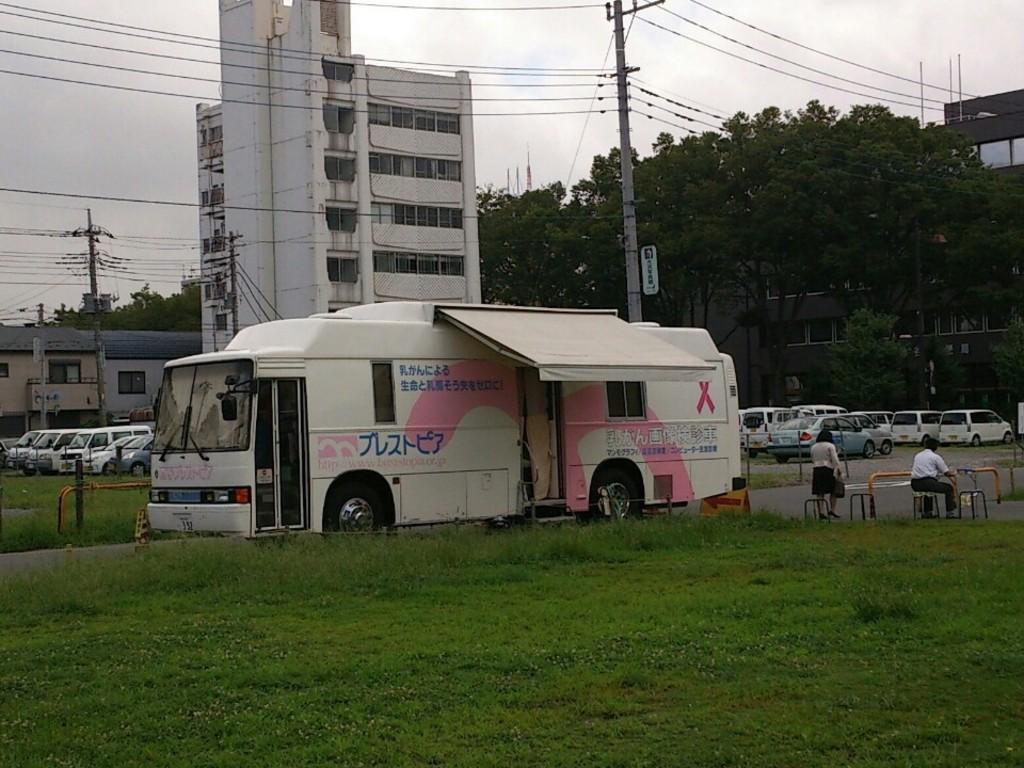What types of objects are on the ground in the image? There are vehicles on the ground in the image. What type of natural vegetation is present in the image? There are trees and grass in the image. What type of structures can be seen in the image? There are buildings with windows in the image. What type of vertical structures are present in the image? There are poles in the image. How many people are visible in the image? There are two persons in the image. What part of the natural environment is visible in the background of the image? The sky is visible in the background of the image. Can you tell me where the comb is located in the image? There is no comb present in the image. What type of wall is visible in the image? There is no wall visible in the image. 